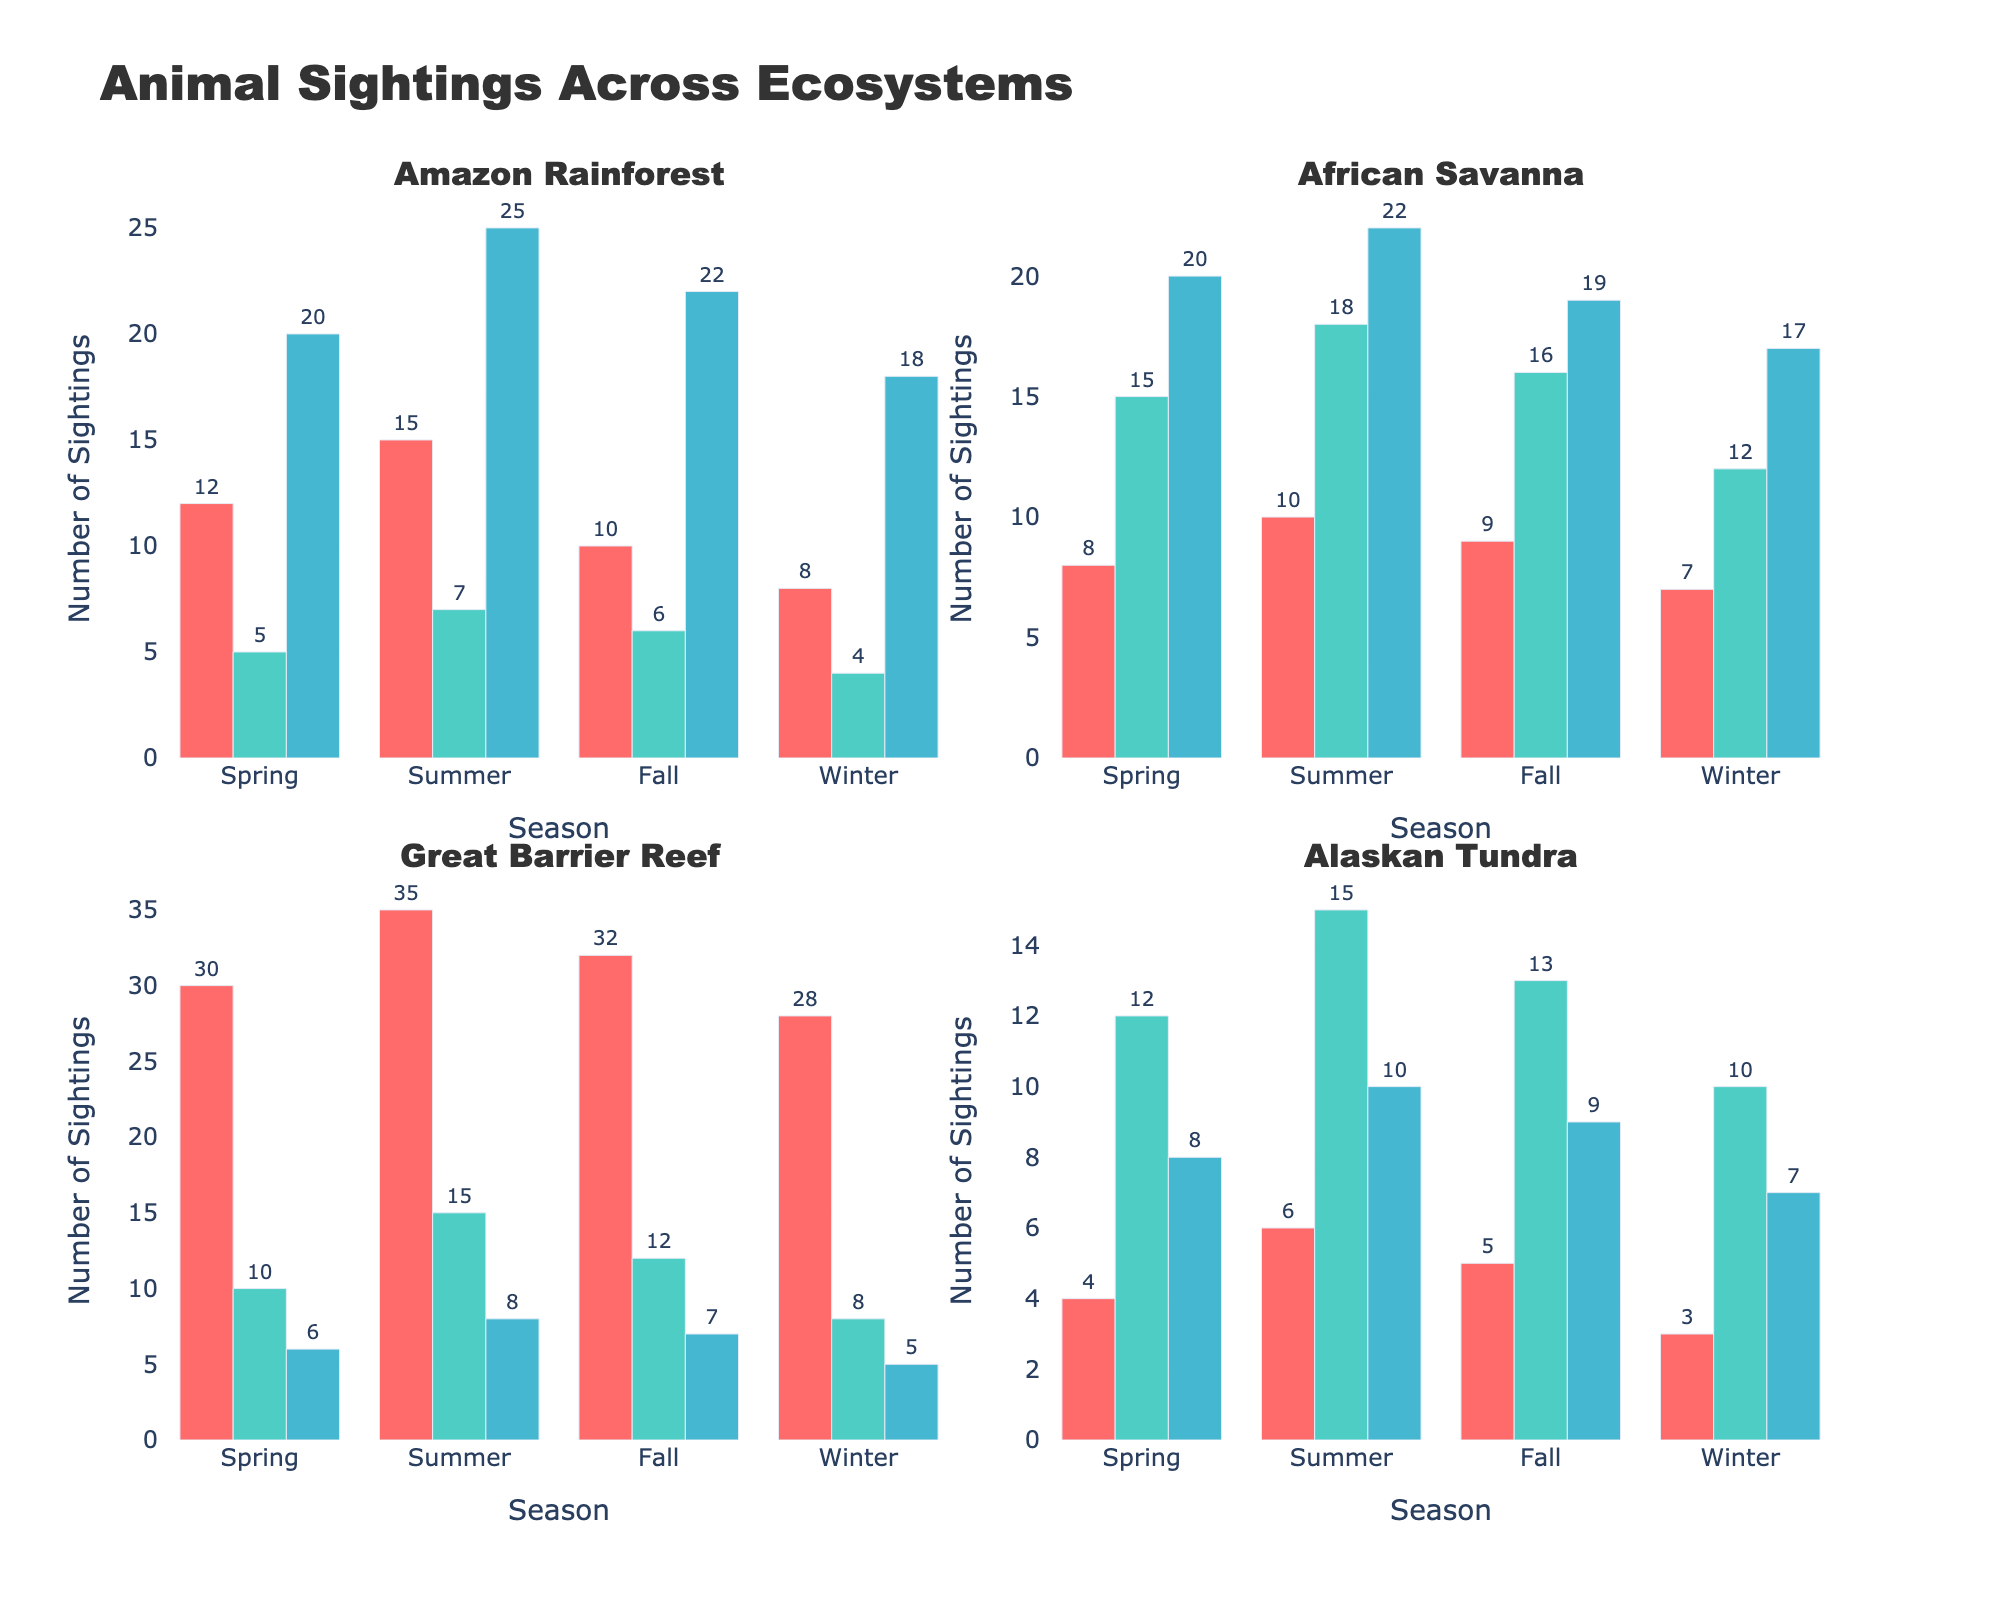How many ecosystems are represented in the figure? By looking at the subplot titles, we can see there are four ecosystems: Amazon Rainforest, African Savanna, Great Barrier Reef, and Alaskan Tundra.
Answer: 4 Which species in the Amazon Rainforest has the highest number of sightings in Summer? In the bar chart for the Amazon Rainforest, the Poison Dart Frog has the tallest bar in Summer.
Answer: Poison Dart Frog Which season shows the highest number of Giraffe sightings in the African Savanna? Looking at the bars for the Giraffe in the African Savanna, Summer has the highest bar.
Answer: Summer What is the total number of animal sightings for the Polar Bear across all seasons in the Alaskan Tundra? Summing up the values for Polar Bear in Spring, Summer, Fall, and Winter: 4 + 6 + 5 + 3 = 18.
Answer: 18 Between the Clownfish and the Sea Turtle in the Great Barrier Reef, which had fewer sightings in the Winter? By comparing the heights of the bars in Winter, Sea Turtle had fewer sightings (8) than Clownfish (28).
Answer: Sea Turtle What is the average number of sightings for the Harpy Eagle in the Amazon Rainforest across all seasons? Adding up the sightings: 5 + 7 + 6 + 4 = 22. Then dividing by 4 seasons gives 22/4 = 5.5.
Answer: 5.5 Which species has the most consistent number of sightings across all seasons in the African Savanna? Giraffe has minimal variation in the number of sightings: Spring (20), Summer (22), Fall (19), Winter (17).
Answer: Giraffe Compare the number of Lion sightings in Summer with the number of Snowy Owl sightings in Fall. Which is higher? The Lion has 10 sightings in Summer, while the Snowy Owl has 9 sightings in Fall.
Answer: Lion In the Amazon Rainforest, how does the number of Jaguar sightings in Spring compare to those in Winter? Comparing the bars, there are 12 Jaguar sightings in Spring and 8 in Winter, so Spring has more.
Answer: Spring Which ecosystem had the highest total number of sightings in Winter? Summing up all species sightings in Winter for each ecosystem: 
- Amazon Rainforest: 8 (Jaguar) + 4 (Harpy Eagle) + 18 (Poison Dart Frog) = 30
- African Savanna: 7 (Lion) + 12 (Elephant) + 17 (Giraffe) = 36
- Great Barrier Reef: 28 (Clownfish) + 8 (Sea Turtle) + 5 (Reef Shark) = 41
- Alaskan Tundra: 3 (Polar Bear) + 10 (Arctic Fox) + 7 (Snowy Owl) = 20
The Great Barrier Reef has the highest total of 41 sightings.
Answer: Great Barrier Reef 